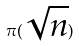Convert formula to latex. <formula><loc_0><loc_0><loc_500><loc_500>\pi ( \sqrt { n } )</formula> 